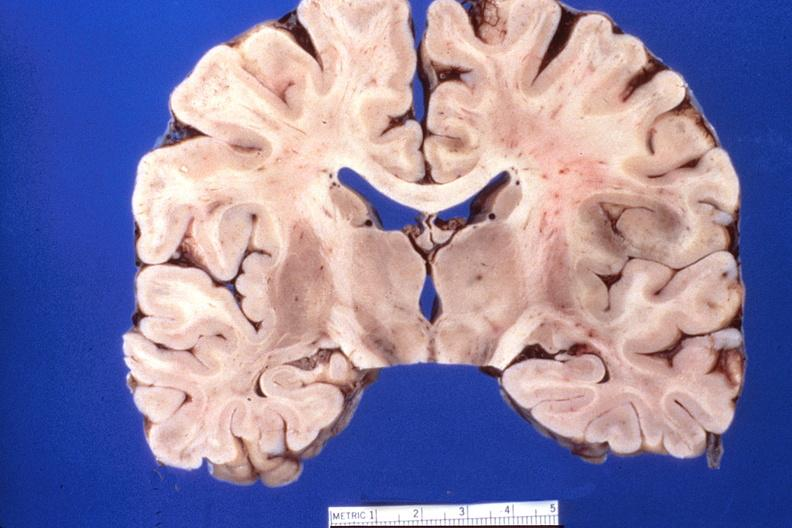does this image show brain, herpes encephalitis?
Answer the question using a single word or phrase. Yes 